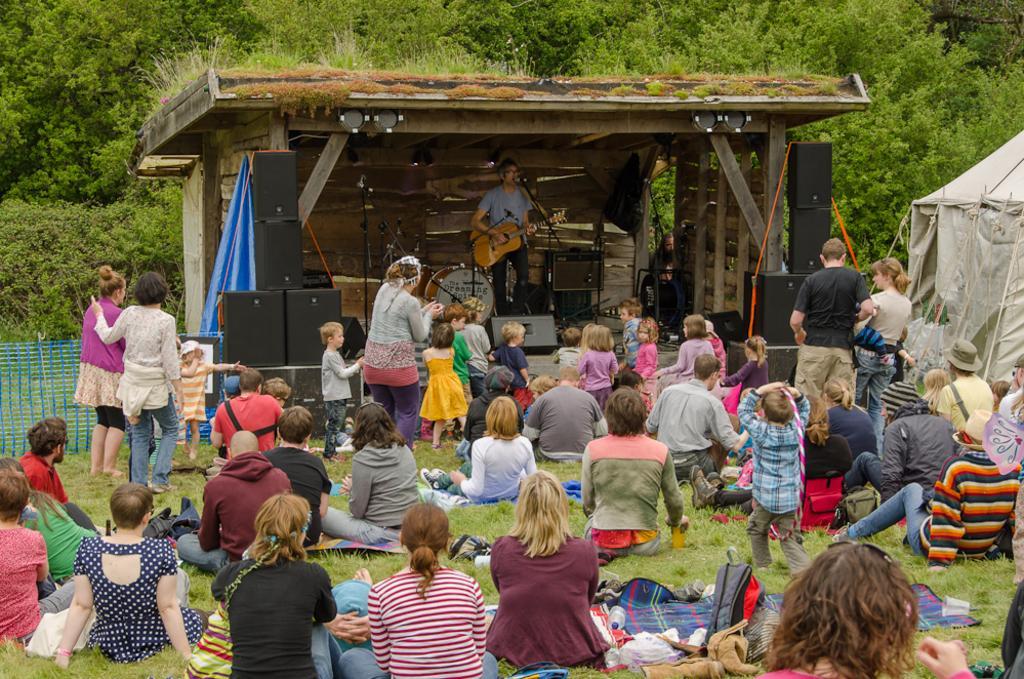In one or two sentences, can you explain what this image depicts? It is an open area or a garden, a lot of people are sitting on the grass in front of them there is a stage, a man is performing music show on the stage beside him on the other side there are big speakers in the background there is a wooden wall and behind it there are lot of trees. 